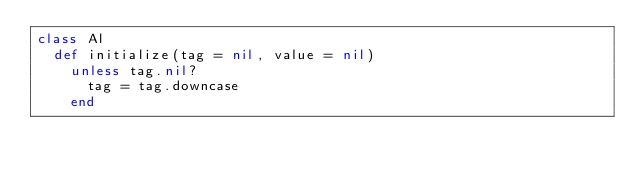Convert code to text. <code><loc_0><loc_0><loc_500><loc_500><_Ruby_>class Al
  def initialize(tag = nil, value = nil)
    unless tag.nil?
      tag = tag.downcase
    end
</code> 